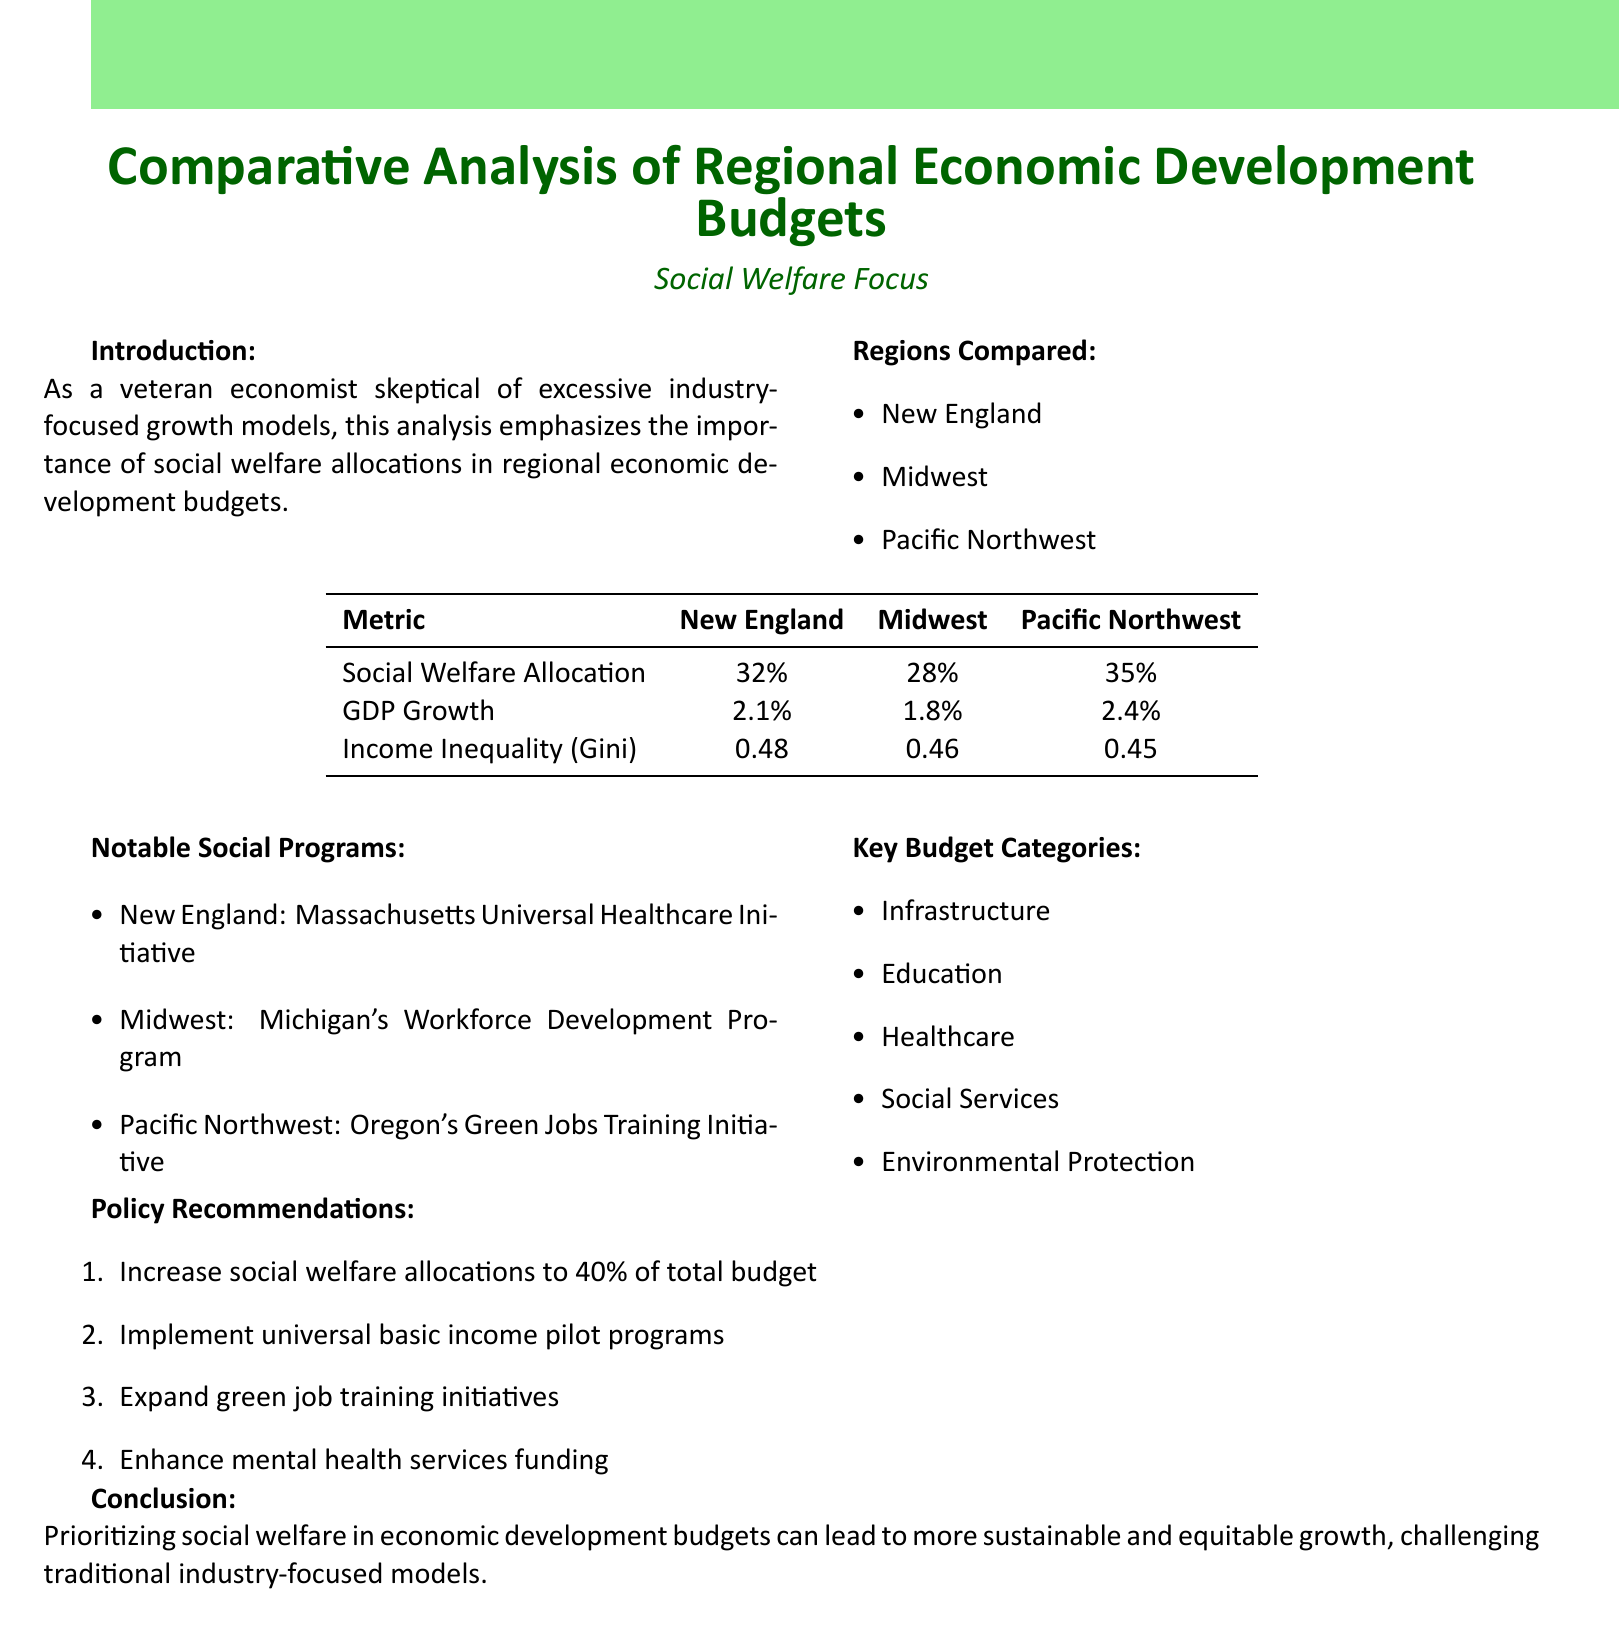What is the social welfare allocation percentage for New England? The document states that the social welfare allocation for New England is 32%.
Answer: 32% What notable social program is mentioned for the Midwest? The document lists Michigan's Workforce Development Program as the notable social program in the Midwest.
Answer: Michigan's Workforce Development Program Which region has the highest GDP growth? The comparative analysis shows that the Pacific Northwest has the highest GDP growth at 2.4%.
Answer: 2.4% What is the Gini coefficient for the Pacific Northwest? According to the document, the Gini coefficient for the Pacific Northwest is 0.45.
Answer: 0.45 What is the recommended increase for social welfare allocations? The policy recommendations suggest increasing social welfare allocations to 40% of the total budget.
Answer: 40% What type of training initiative is highlighted for the Pacific Northwest? The document highlights Oregon's Green Jobs Training Initiative as a significant program in the Pacific Northwest.
Answer: Oregon's Green Jobs Training Initiative What is the percentage of social welfare allocation in the Midwest? The social welfare allocation for the Midwest, as mentioned in the document, is 28%.
Answer: 28% What key budget category is related to mental health services? The document lists social services as a key budget category associated with mental health services.
Answer: Social Services 